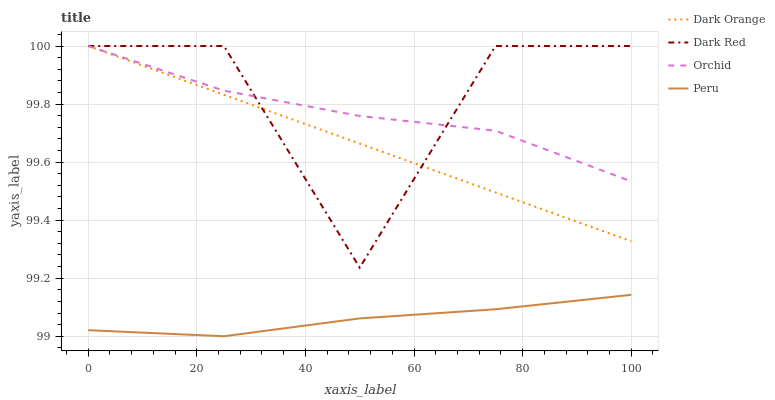Does Peru have the minimum area under the curve?
Answer yes or no. Yes. Does Dark Red have the maximum area under the curve?
Answer yes or no. Yes. Does Orchid have the minimum area under the curve?
Answer yes or no. No. Does Orchid have the maximum area under the curve?
Answer yes or no. No. Is Dark Orange the smoothest?
Answer yes or no. Yes. Is Dark Red the roughest?
Answer yes or no. Yes. Is Orchid the smoothest?
Answer yes or no. No. Is Orchid the roughest?
Answer yes or no. No. Does Peru have the lowest value?
Answer yes or no. Yes. Does Orchid have the lowest value?
Answer yes or no. No. Does Dark Red have the highest value?
Answer yes or no. Yes. Does Peru have the highest value?
Answer yes or no. No. Is Peru less than Dark Orange?
Answer yes or no. Yes. Is Orchid greater than Peru?
Answer yes or no. Yes. Does Dark Red intersect Orchid?
Answer yes or no. Yes. Is Dark Red less than Orchid?
Answer yes or no. No. Is Dark Red greater than Orchid?
Answer yes or no. No. Does Peru intersect Dark Orange?
Answer yes or no. No. 